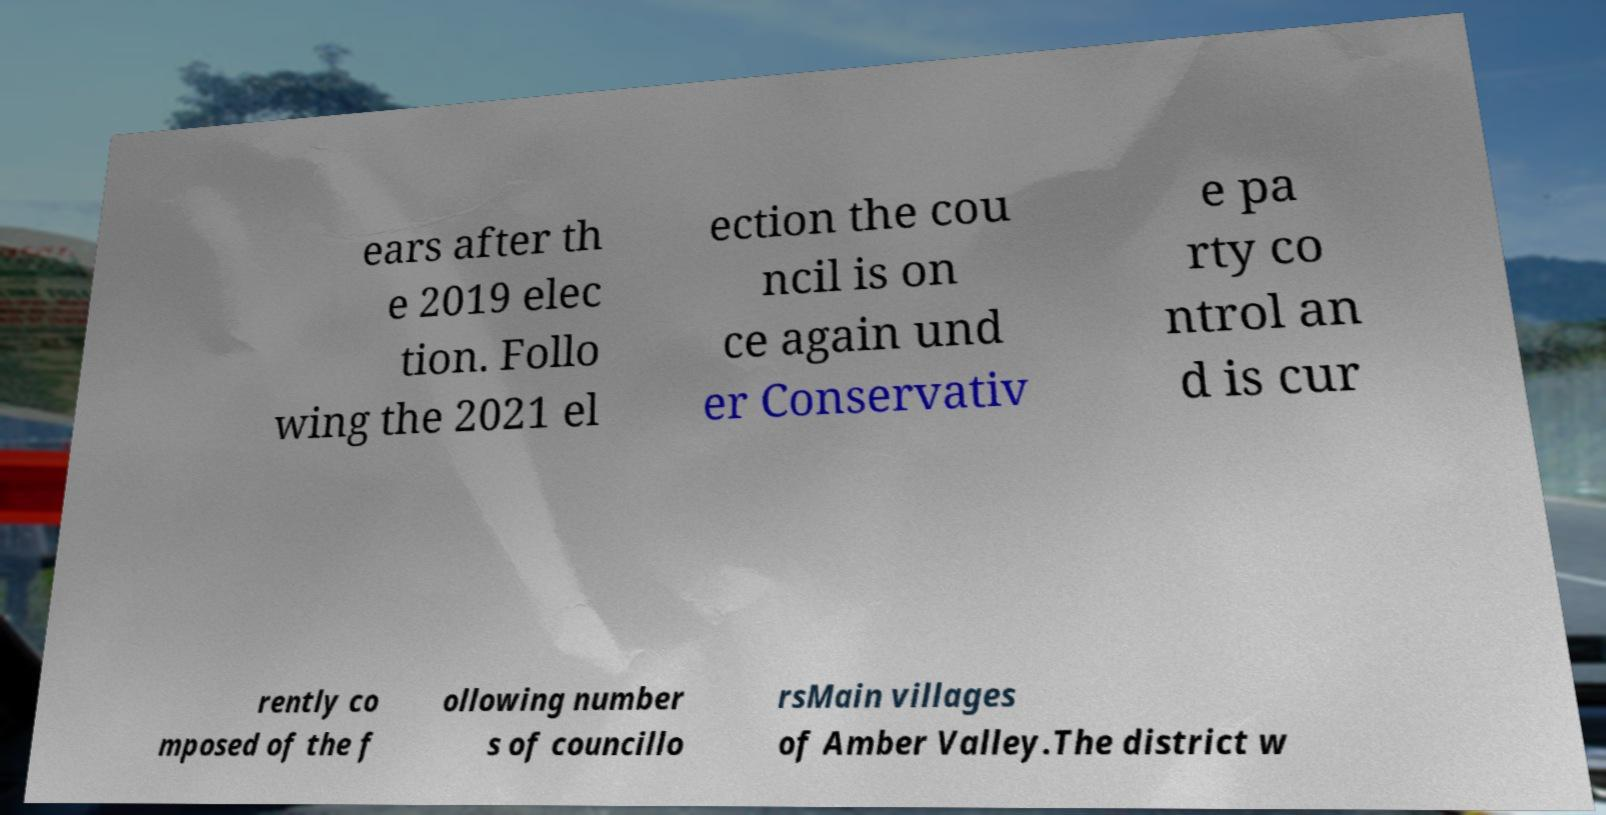There's text embedded in this image that I need extracted. Can you transcribe it verbatim? ears after th e 2019 elec tion. Follo wing the 2021 el ection the cou ncil is on ce again und er Conservativ e pa rty co ntrol an d is cur rently co mposed of the f ollowing number s of councillo rsMain villages of Amber Valley.The district w 